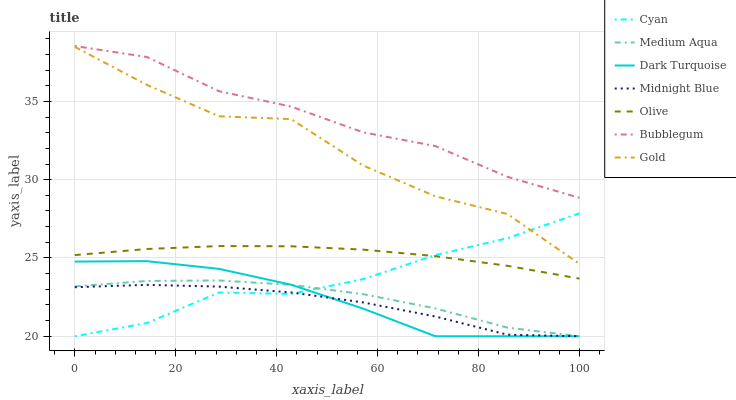Does Midnight Blue have the minimum area under the curve?
Answer yes or no. Yes. Does Bubblegum have the maximum area under the curve?
Answer yes or no. Yes. Does Gold have the minimum area under the curve?
Answer yes or no. No. Does Gold have the maximum area under the curve?
Answer yes or no. No. Is Olive the smoothest?
Answer yes or no. Yes. Is Gold the roughest?
Answer yes or no. Yes. Is Dark Turquoise the smoothest?
Answer yes or no. No. Is Dark Turquoise the roughest?
Answer yes or no. No. Does Gold have the lowest value?
Answer yes or no. No. Does Bubblegum have the highest value?
Answer yes or no. Yes. Does Gold have the highest value?
Answer yes or no. No. Is Medium Aqua less than Gold?
Answer yes or no. Yes. Is Gold greater than Midnight Blue?
Answer yes or no. Yes. Does Cyan intersect Gold?
Answer yes or no. Yes. Is Cyan less than Gold?
Answer yes or no. No. Is Cyan greater than Gold?
Answer yes or no. No. Does Medium Aqua intersect Gold?
Answer yes or no. No. 